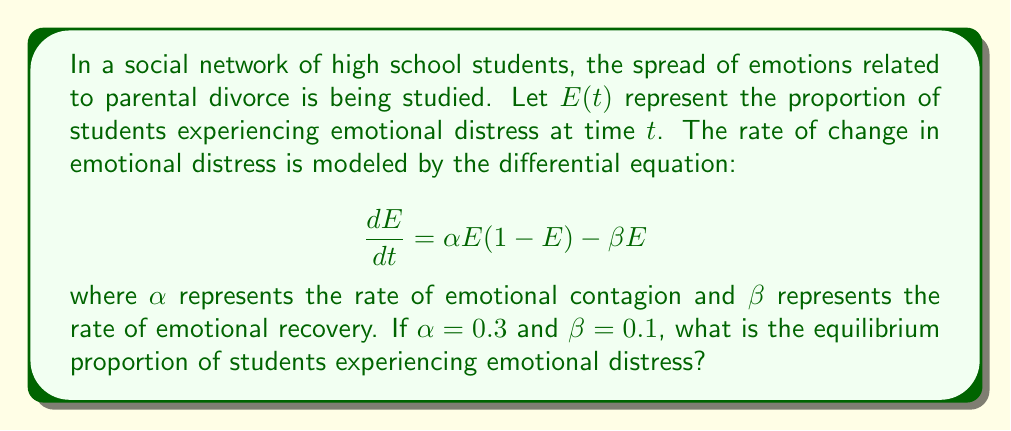Provide a solution to this math problem. To find the equilibrium proportion, we need to solve for $E$ when $\frac{dE}{dt} = 0$. This represents the point at which the proportion of students experiencing emotional distress is not changing.

1) Set the differential equation equal to zero:
   $$0 = \alpha E(1-E) - \beta E$$

2) Substitute the given values for $\alpha$ and $\beta$:
   $$0 = 0.3E(1-E) - 0.1E$$

3) Expand the equation:
   $$0 = 0.3E - 0.3E^2 - 0.1E$$

4) Combine like terms:
   $$0 = 0.2E - 0.3E^2$$

5) Factor out $E$:
   $$0 = E(0.2 - 0.3E)$$

6) Solve for $E$:
   Either $E = 0$ or $0.2 - 0.3E = 0$
   
   From the second equation:
   $$0.2 = 0.3E$$
   $$E = \frac{0.2}{0.3} \approx 0.667$$

7) Check both solutions:
   $E = 0$ represents no emotional distress, which is a trivial equilibrium.
   $E \approx 0.667$ represents a non-trivial equilibrium where about 66.7% of students are experiencing emotional distress.

The non-trivial equilibrium is the more interesting and relevant solution in this context.
Answer: The equilibrium proportion of students experiencing emotional distress is approximately 0.667 or 66.7%. 